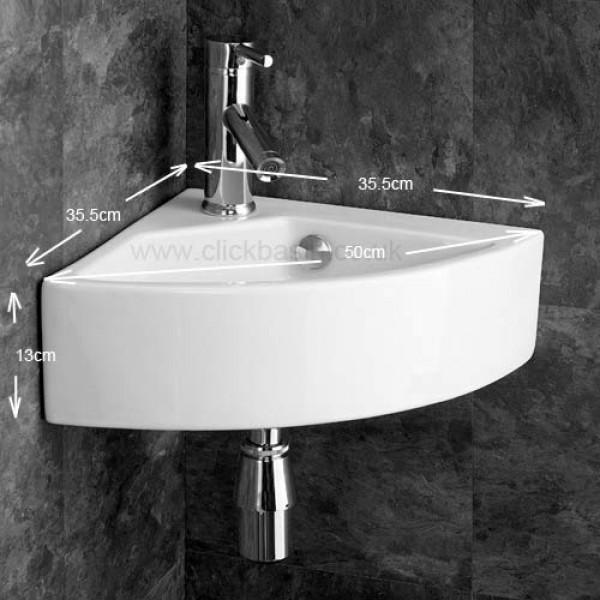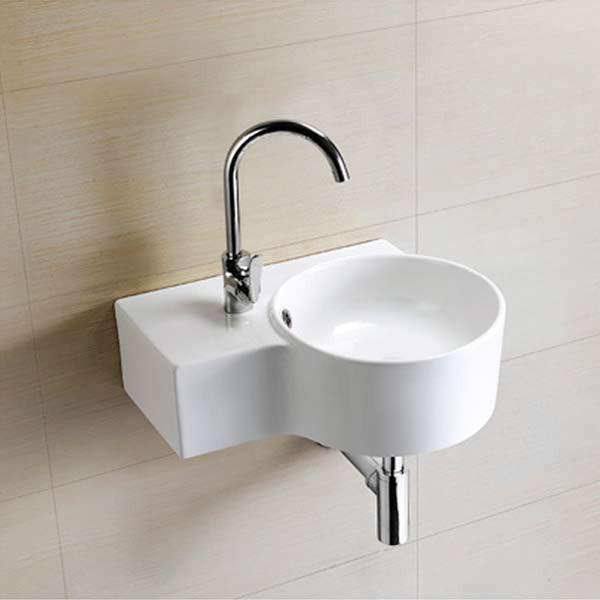The first image is the image on the left, the second image is the image on the right. For the images shown, is this caption "The sink on the left fits in a corner, and the sink on the right includes a spout mounted to a rectangular white component." true? Answer yes or no. Yes. 